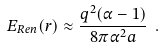<formula> <loc_0><loc_0><loc_500><loc_500>E _ { R e n } ( r ) \approx \frac { q ^ { 2 } ( \alpha - 1 ) } { 8 \pi \alpha ^ { 2 } a } \ .</formula> 